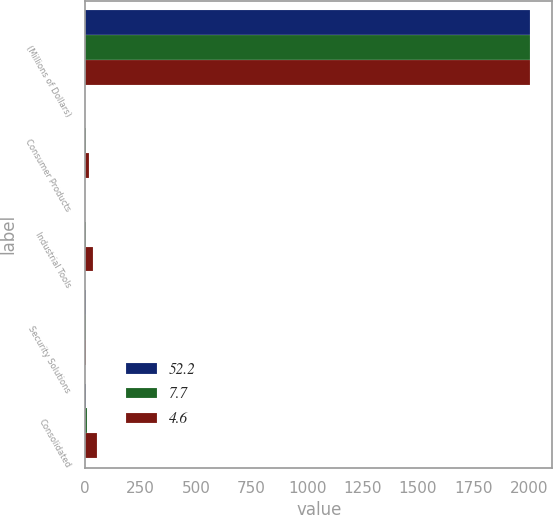Convert chart to OTSL. <chart><loc_0><loc_0><loc_500><loc_500><stacked_bar_chart><ecel><fcel>(Millions of Dollars)<fcel>Consumer Products<fcel>Industrial Tools<fcel>Security Solutions<fcel>Consolidated<nl><fcel>52.2<fcel>2005<fcel>0.5<fcel>1<fcel>3.1<fcel>4.6<nl><fcel>7.7<fcel>2004<fcel>1.3<fcel>2.9<fcel>3.5<fcel>7.7<nl><fcel>4.6<fcel>2003<fcel>15.2<fcel>35.7<fcel>1.3<fcel>52.2<nl></chart> 